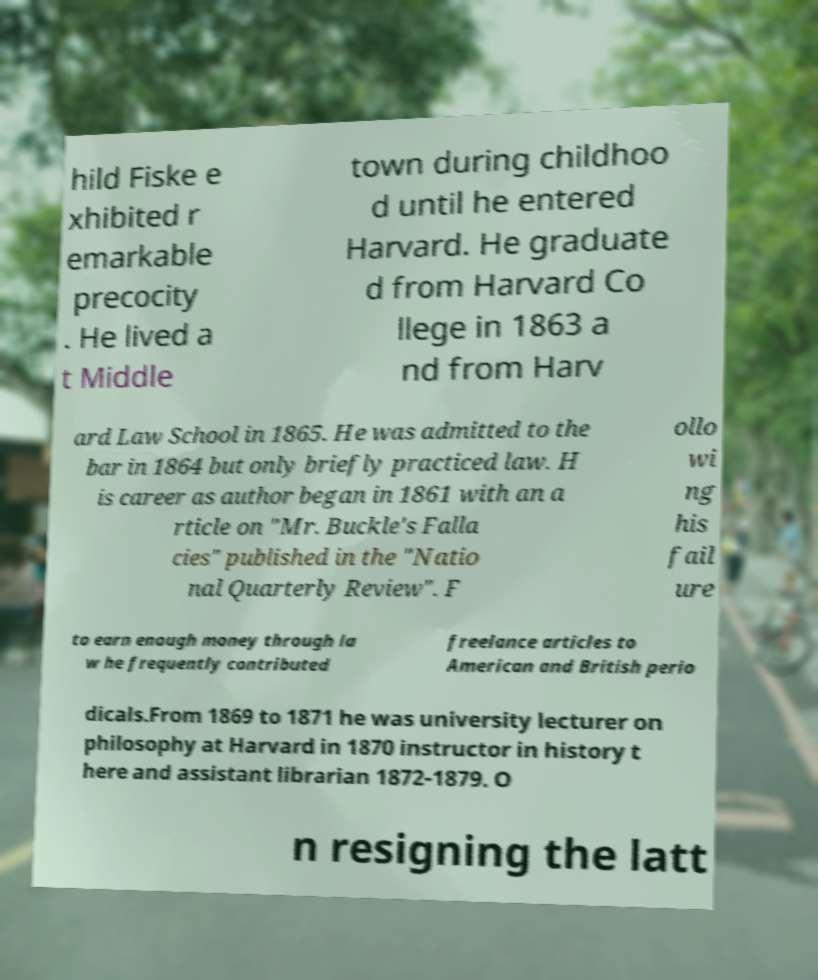Could you assist in decoding the text presented in this image and type it out clearly? hild Fiske e xhibited r emarkable precocity . He lived a t Middle town during childhoo d until he entered Harvard. He graduate d from Harvard Co llege in 1863 a nd from Harv ard Law School in 1865. He was admitted to the bar in 1864 but only briefly practiced law. H is career as author began in 1861 with an a rticle on "Mr. Buckle's Falla cies" published in the "Natio nal Quarterly Review". F ollo wi ng his fail ure to earn enough money through la w he frequently contributed freelance articles to American and British perio dicals.From 1869 to 1871 he was university lecturer on philosophy at Harvard in 1870 instructor in history t here and assistant librarian 1872-1879. O n resigning the latt 